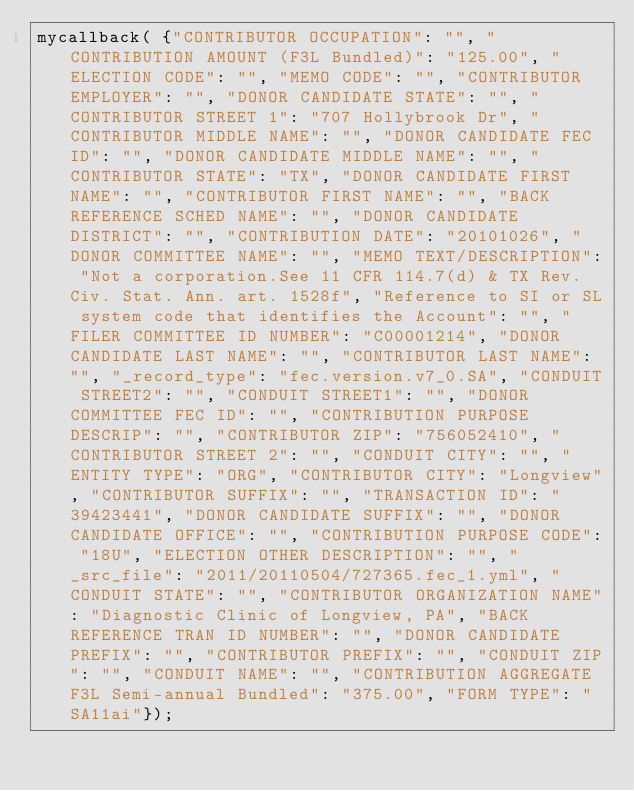Convert code to text. <code><loc_0><loc_0><loc_500><loc_500><_JavaScript_>mycallback( {"CONTRIBUTOR OCCUPATION": "", "CONTRIBUTION AMOUNT (F3L Bundled)": "125.00", "ELECTION CODE": "", "MEMO CODE": "", "CONTRIBUTOR EMPLOYER": "", "DONOR CANDIDATE STATE": "", "CONTRIBUTOR STREET 1": "707 Hollybrook Dr", "CONTRIBUTOR MIDDLE NAME": "", "DONOR CANDIDATE FEC ID": "", "DONOR CANDIDATE MIDDLE NAME": "", "CONTRIBUTOR STATE": "TX", "DONOR CANDIDATE FIRST NAME": "", "CONTRIBUTOR FIRST NAME": "", "BACK REFERENCE SCHED NAME": "", "DONOR CANDIDATE DISTRICT": "", "CONTRIBUTION DATE": "20101026", "DONOR COMMITTEE NAME": "", "MEMO TEXT/DESCRIPTION": "Not a corporation.See 11 CFR 114.7(d) & TX Rev. Civ. Stat. Ann. art. 1528f", "Reference to SI or SL system code that identifies the Account": "", "FILER COMMITTEE ID NUMBER": "C00001214", "DONOR CANDIDATE LAST NAME": "", "CONTRIBUTOR LAST NAME": "", "_record_type": "fec.version.v7_0.SA", "CONDUIT STREET2": "", "CONDUIT STREET1": "", "DONOR COMMITTEE FEC ID": "", "CONTRIBUTION PURPOSE DESCRIP": "", "CONTRIBUTOR ZIP": "756052410", "CONTRIBUTOR STREET 2": "", "CONDUIT CITY": "", "ENTITY TYPE": "ORG", "CONTRIBUTOR CITY": "Longview", "CONTRIBUTOR SUFFIX": "", "TRANSACTION ID": "39423441", "DONOR CANDIDATE SUFFIX": "", "DONOR CANDIDATE OFFICE": "", "CONTRIBUTION PURPOSE CODE": "18U", "ELECTION OTHER DESCRIPTION": "", "_src_file": "2011/20110504/727365.fec_1.yml", "CONDUIT STATE": "", "CONTRIBUTOR ORGANIZATION NAME": "Diagnostic Clinic of Longview, PA", "BACK REFERENCE TRAN ID NUMBER": "", "DONOR CANDIDATE PREFIX": "", "CONTRIBUTOR PREFIX": "", "CONDUIT ZIP": "", "CONDUIT NAME": "", "CONTRIBUTION AGGREGATE F3L Semi-annual Bundled": "375.00", "FORM TYPE": "SA11ai"});
</code> 